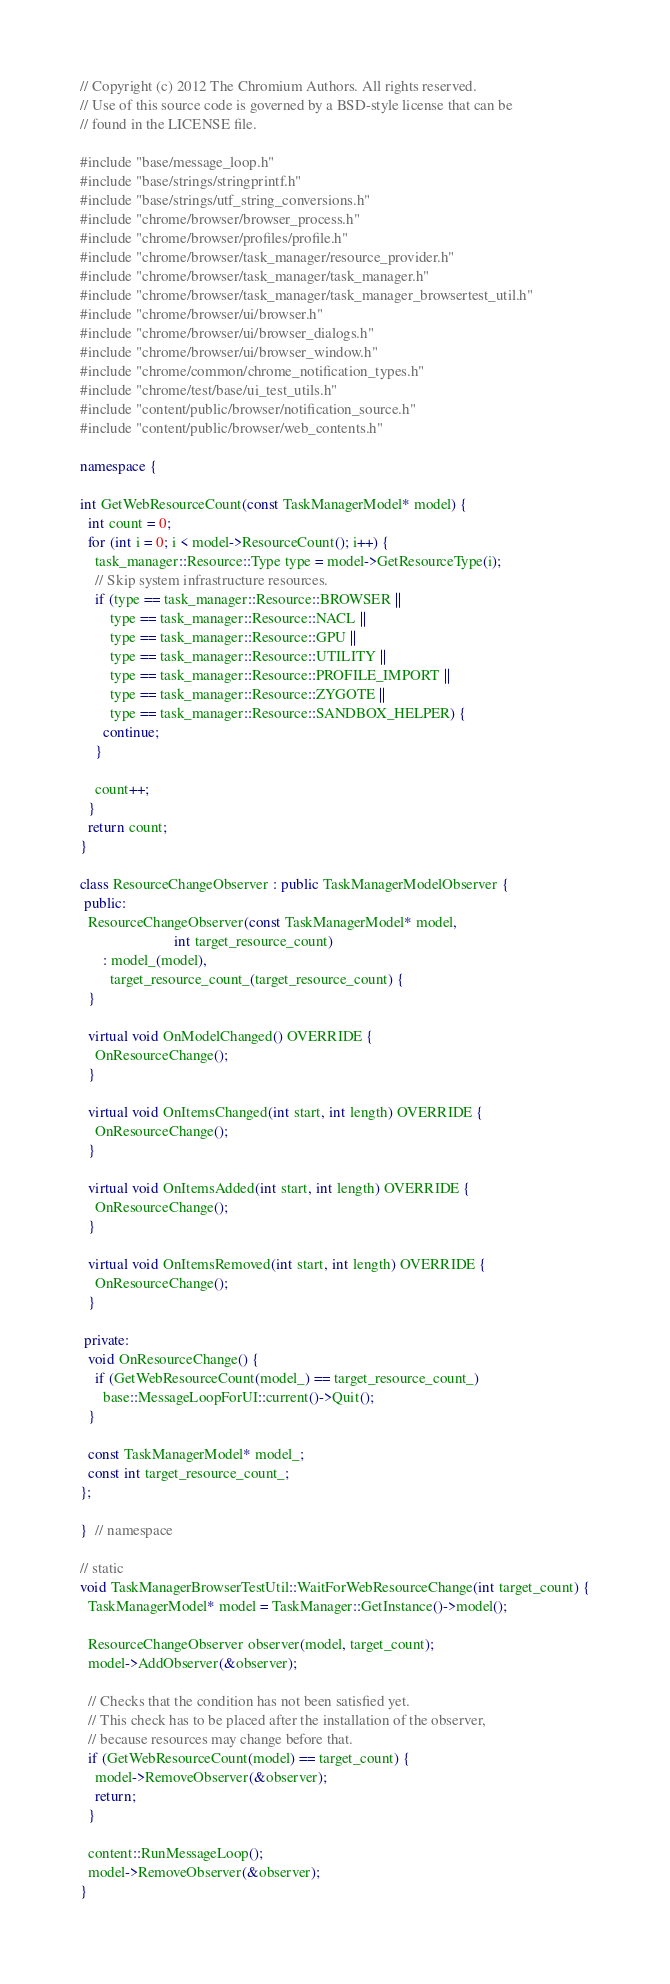<code> <loc_0><loc_0><loc_500><loc_500><_C++_>// Copyright (c) 2012 The Chromium Authors. All rights reserved.
// Use of this source code is governed by a BSD-style license that can be
// found in the LICENSE file.

#include "base/message_loop.h"
#include "base/strings/stringprintf.h"
#include "base/strings/utf_string_conversions.h"
#include "chrome/browser/browser_process.h"
#include "chrome/browser/profiles/profile.h"
#include "chrome/browser/task_manager/resource_provider.h"
#include "chrome/browser/task_manager/task_manager.h"
#include "chrome/browser/task_manager/task_manager_browsertest_util.h"
#include "chrome/browser/ui/browser.h"
#include "chrome/browser/ui/browser_dialogs.h"
#include "chrome/browser/ui/browser_window.h"
#include "chrome/common/chrome_notification_types.h"
#include "chrome/test/base/ui_test_utils.h"
#include "content/public/browser/notification_source.h"
#include "content/public/browser/web_contents.h"

namespace {

int GetWebResourceCount(const TaskManagerModel* model) {
  int count = 0;
  for (int i = 0; i < model->ResourceCount(); i++) {
    task_manager::Resource::Type type = model->GetResourceType(i);
    // Skip system infrastructure resources.
    if (type == task_manager::Resource::BROWSER ||
        type == task_manager::Resource::NACL ||
        type == task_manager::Resource::GPU ||
        type == task_manager::Resource::UTILITY ||
        type == task_manager::Resource::PROFILE_IMPORT ||
        type == task_manager::Resource::ZYGOTE ||
        type == task_manager::Resource::SANDBOX_HELPER) {
      continue;
    }

    count++;
  }
  return count;
}

class ResourceChangeObserver : public TaskManagerModelObserver {
 public:
  ResourceChangeObserver(const TaskManagerModel* model,
                         int target_resource_count)
      : model_(model),
        target_resource_count_(target_resource_count) {
  }

  virtual void OnModelChanged() OVERRIDE {
    OnResourceChange();
  }

  virtual void OnItemsChanged(int start, int length) OVERRIDE {
    OnResourceChange();
  }

  virtual void OnItemsAdded(int start, int length) OVERRIDE {
    OnResourceChange();
  }

  virtual void OnItemsRemoved(int start, int length) OVERRIDE {
    OnResourceChange();
  }

 private:
  void OnResourceChange() {
    if (GetWebResourceCount(model_) == target_resource_count_)
      base::MessageLoopForUI::current()->Quit();
  }

  const TaskManagerModel* model_;
  const int target_resource_count_;
};

}  // namespace

// static
void TaskManagerBrowserTestUtil::WaitForWebResourceChange(int target_count) {
  TaskManagerModel* model = TaskManager::GetInstance()->model();

  ResourceChangeObserver observer(model, target_count);
  model->AddObserver(&observer);

  // Checks that the condition has not been satisfied yet.
  // This check has to be placed after the installation of the observer,
  // because resources may change before that.
  if (GetWebResourceCount(model) == target_count) {
    model->RemoveObserver(&observer);
    return;
  }

  content::RunMessageLoop();
  model->RemoveObserver(&observer);
}
</code> 